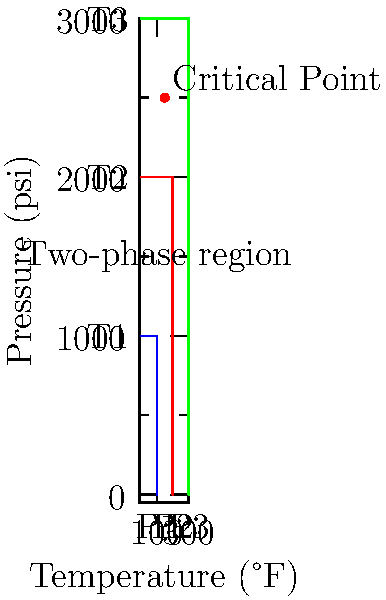Using the provided phase diagram for a reservoir fluid, analyze how the critical point and two-phase region change as temperature increases from T1 to T3. How does this affect the behavior of the fluid in terms of its compressibility and volume? What implications does this have for enhanced oil recovery techniques? To analyze the PVT behavior of the reservoir fluid using the given phase diagram:

1. Temperature effect:
   As temperature increases from T1 to T3, we observe:
   a) The critical point moves to higher pressures.
   b) The two-phase region shrinks.

2. Compressibility:
   a) At T1: The fluid is more compressible due to the larger two-phase region.
   b) At T3: The fluid becomes less compressible as it moves closer to supercritical conditions.

3. Volume:
   a) At T1: The fluid experiences larger volume changes with pressure variations.
   b) At T3: Volume changes are less pronounced due to reduced compressibility.

4. Implications for enhanced oil recovery (EOR):
   a) At lower temperatures (T1):
      - Larger two-phase region allows for more effective gas injection EOR techniques.
      - Higher compressibility can lead to better sweep efficiency.
   b) At higher temperatures (T3):
      - Reduced two-phase region may limit the effectiveness of gas injection methods.
      - Lower compressibility could result in more stable displacement fronts.

5. PVT behavior analysis:
   a) The critical point shift indicates that higher pressures are required to maintain a single-phase fluid at elevated temperatures.
   b) The shrinking two-phase region suggests that the fluid becomes more homogeneous at higher temperatures, potentially affecting miscibility in EOR processes.

6. EOR technique considerations:
   a) For gas injection methods: Lower temperatures (T1) may be more favorable due to the larger two-phase region and higher compressibility.
   b) For thermal EOR methods: Higher temperatures (T3) could be beneficial by reducing the two-phase region and improving fluid mobility.

In conclusion, the PVT behavior changes significantly with temperature, affecting fluid properties and the choice of optimal EOR techniques.
Answer: As temperature increases, the critical point moves to higher pressures, the two-phase region shrinks, and the fluid becomes less compressible. This affects EOR by favoring gas injection at lower temperatures and thermal methods at higher temperatures. 